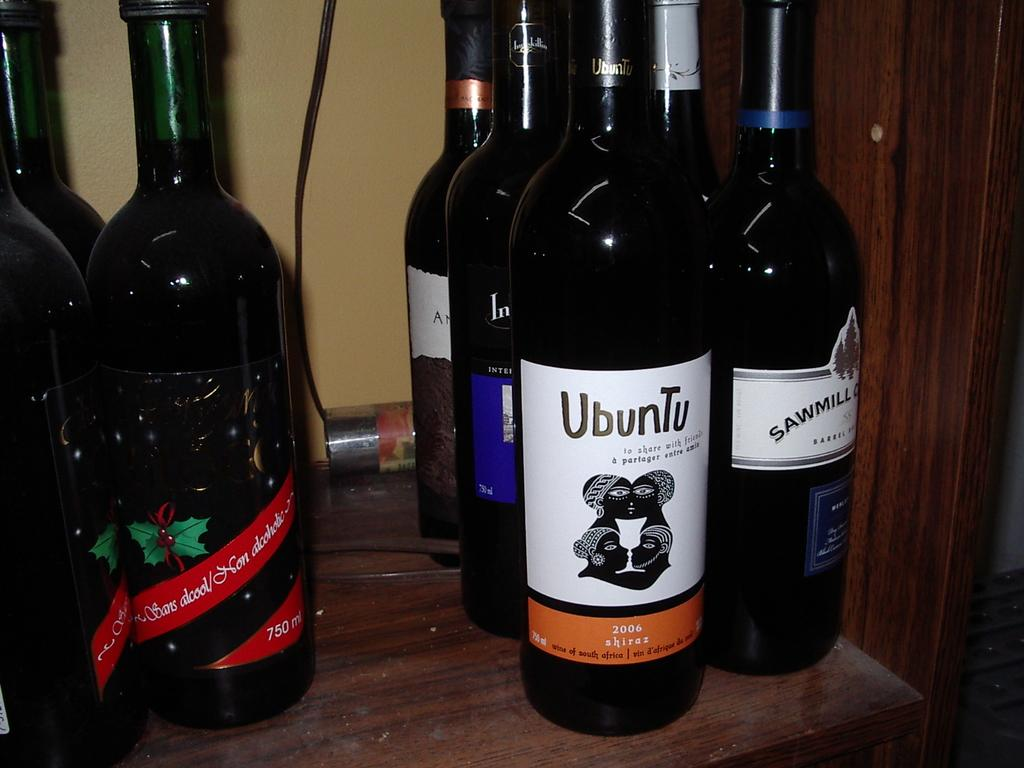Provide a one-sentence caption for the provided image. a group of alcohol bottles, one saying Ubuntu and it's from Africa. 